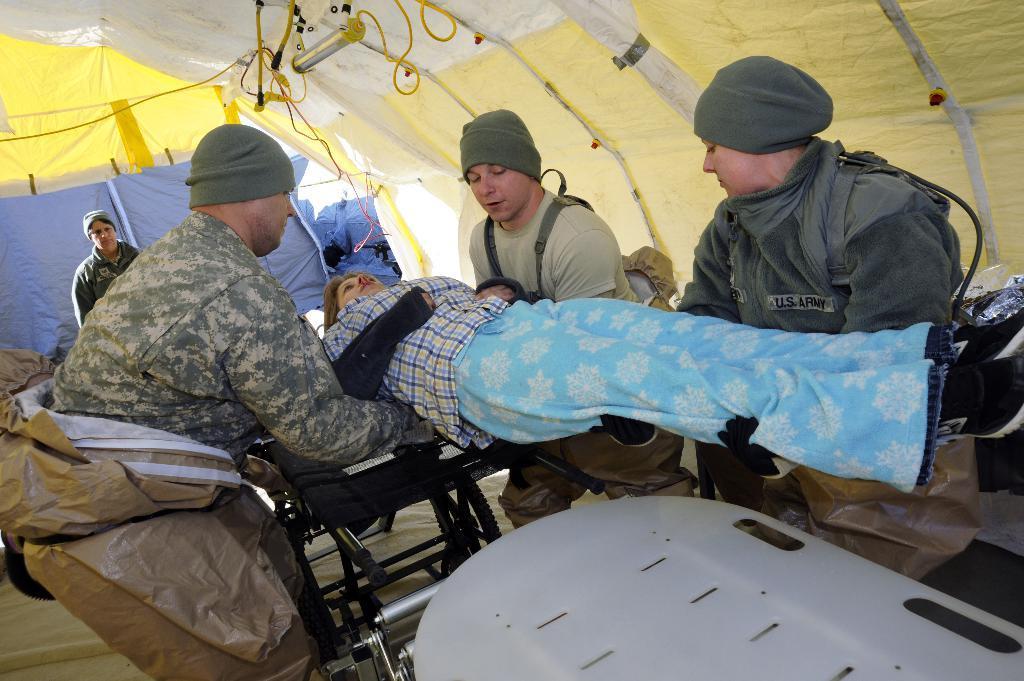Can you describe this image briefly? This picture is clicked inside. In the center we can see the group of persons standing on the ground and holding another person. In the foreground there is a white color object seems to be the stretcher and we can see the wheel chair and some other objects placed on the ground. At the top we can see the roof of a tent and we can see the ropes. In the background there is a person standing on the ground and we can see some other objects. 